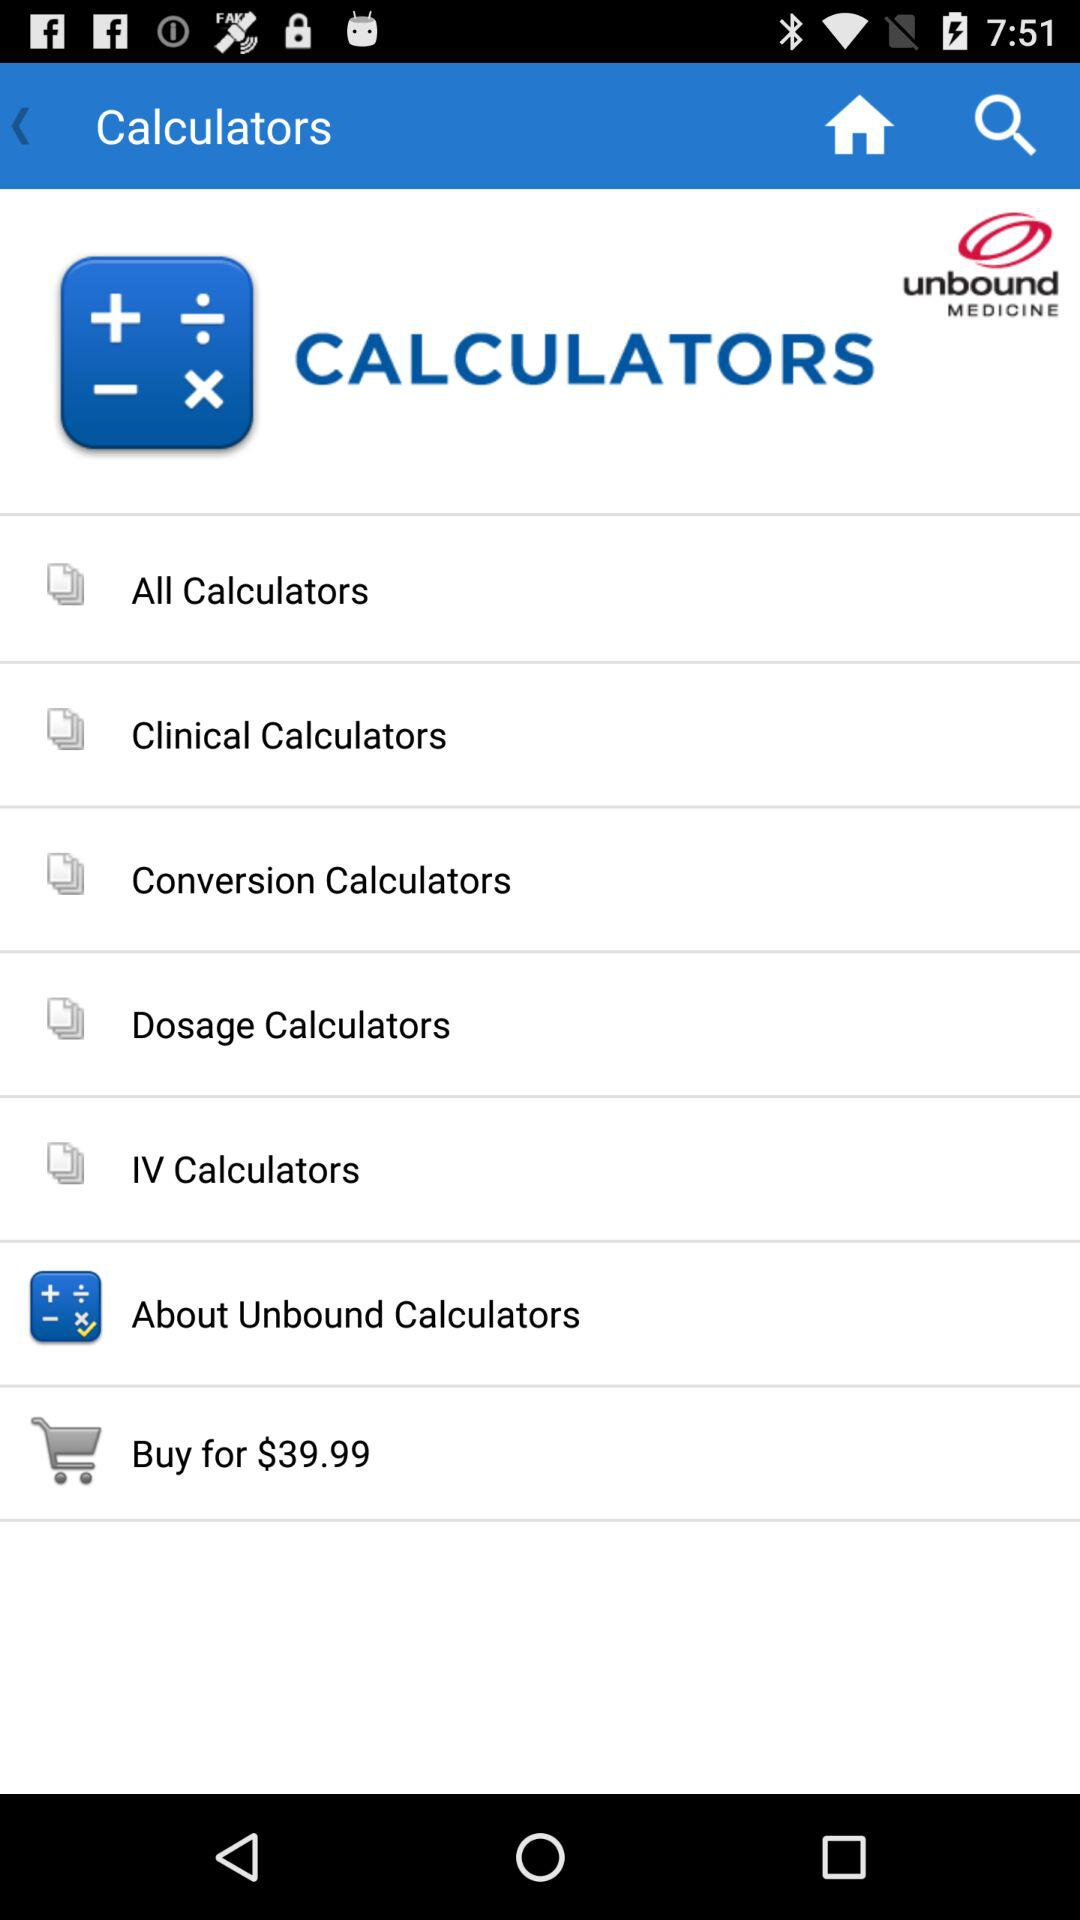What is the price of the "Unbound Calculators"? The price is $39.99. 